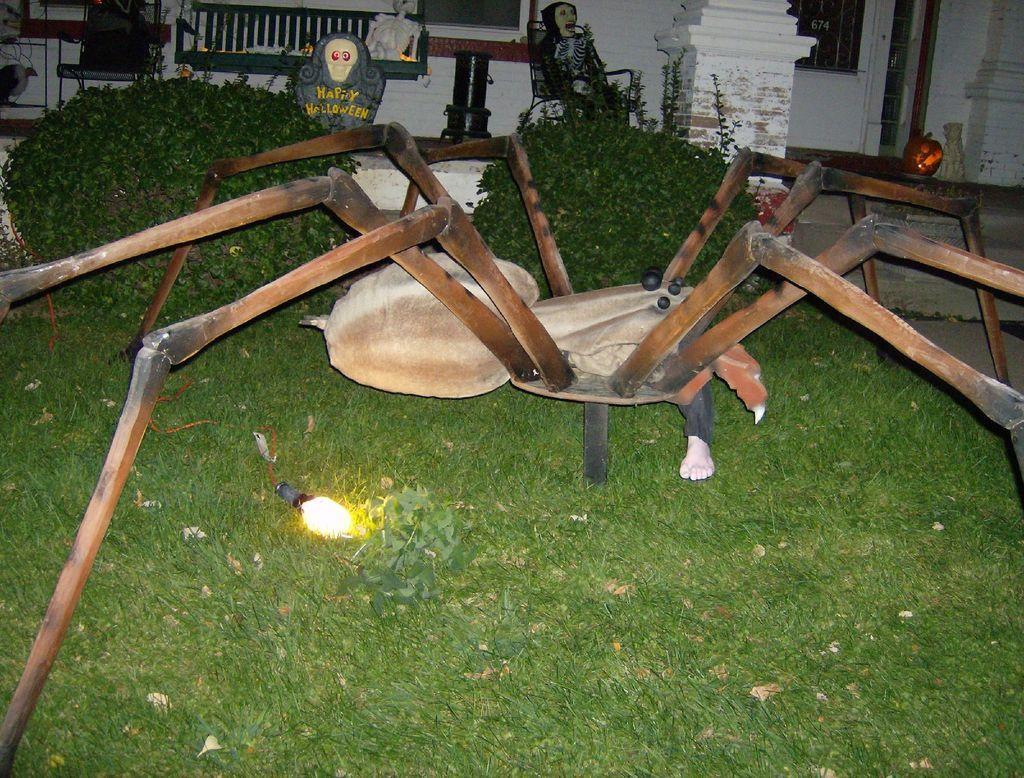Please provide a concise description of this image. Front portion of the image we can see spider, person leg, light, grass and bushes. Background portion of the image we can see windows, walls, pillar, chair, bench, skeletons, stone and things. 